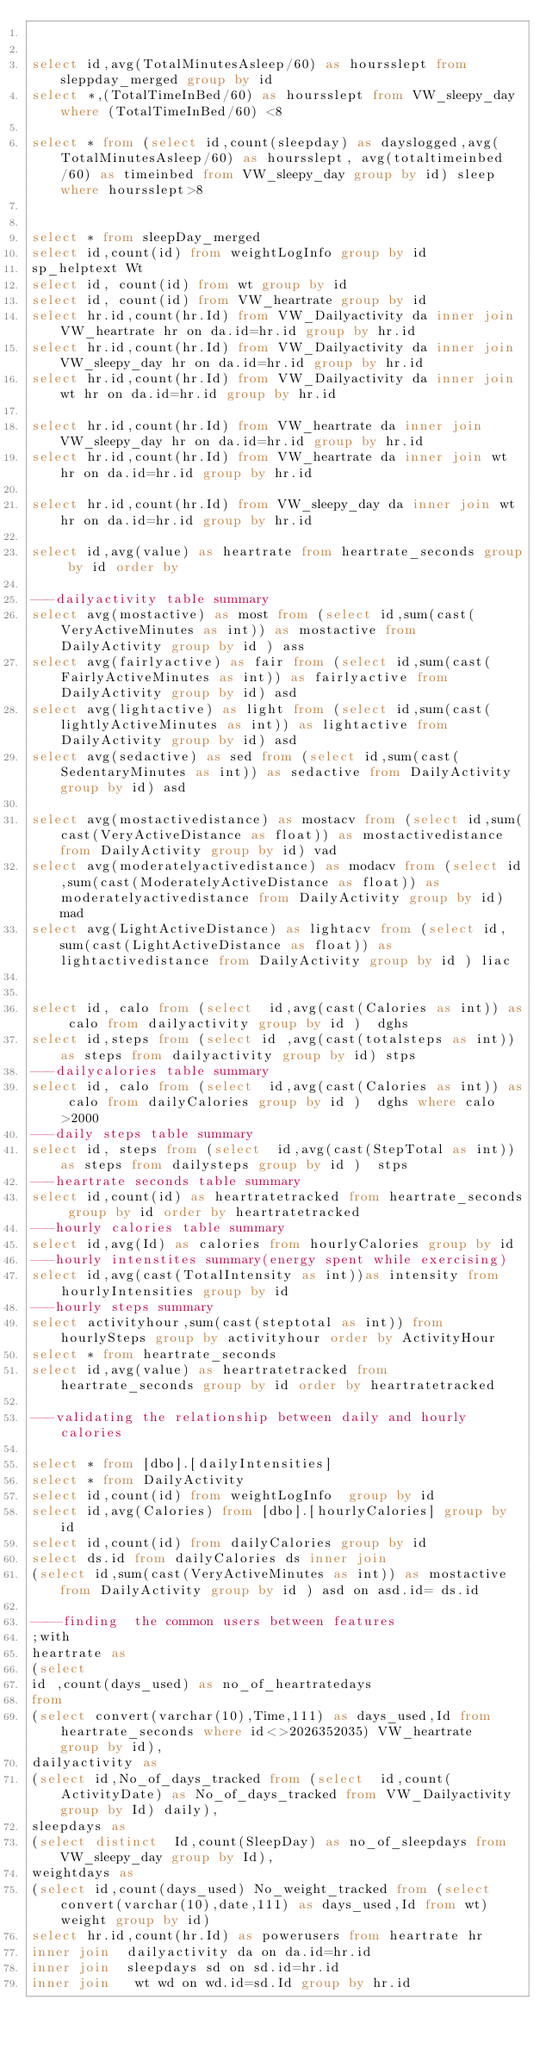<code> <loc_0><loc_0><loc_500><loc_500><_SQL_>

select id,avg(TotalMinutesAsleep/60) as hoursslept from sleppday_merged group by id
select *,(TotalTimeInBed/60) as hoursslept from VW_sleepy_day where (TotalTimeInBed/60) <8

select * from (select id,count(sleepday) as dayslogged,avg(TotalMinutesAsleep/60) as hoursslept, avg(totaltimeinbed/60) as timeinbed from VW_sleepy_day group by id) sleep where hoursslept>8


select * from sleepDay_merged
select id,count(id) from weightLogInfo group by id
sp_helptext Wt
select id, count(id) from wt group by id
select id, count(id) from VW_heartrate group by id
select hr.id,count(hr.Id) from VW_Dailyactivity da inner join VW_heartrate hr on da.id=hr.id group by hr.id
select hr.id,count(hr.Id) from VW_Dailyactivity da inner join VW_sleepy_day hr on da.id=hr.id group by hr.id
select hr.id,count(hr.Id) from VW_Dailyactivity da inner join wt hr on da.id=hr.id group by hr.id

select hr.id,count(hr.Id) from VW_heartrate da inner join VW_sleepy_day hr on da.id=hr.id group by hr.id
select hr.id,count(hr.Id) from VW_heartrate da inner join wt hr on da.id=hr.id group by hr.id

select hr.id,count(hr.Id) from VW_sleepy_day da inner join wt hr on da.id=hr.id group by hr.id

select id,avg(value) as heartrate from heartrate_seconds group by id order by 

---dailyactivity table summary
select avg(mostactive) as most from (select id,sum(cast(VeryActiveMinutes as int)) as mostactive from DailyActivity group by id ) ass
select avg(fairlyactive) as fair from (select id,sum(cast(FairlyActiveMinutes as int)) as fairlyactive from DailyActivity group by id) asd
select avg(lightactive) as light from (select id,sum(cast(lightlyActiveMinutes as int)) as lightactive from DailyActivity group by id) asd
select avg(sedactive) as sed from (select id,sum(cast(SedentaryMinutes as int)) as sedactive from DailyActivity group by id) asd
 
select avg(mostactivedistance) as mostacv from (select id,sum(cast(VeryActiveDistance as float)) as mostactivedistance from DailyActivity group by id) vad
select avg(moderatelyactivedistance) as modacv from (select id,sum(cast(ModeratelyActiveDistance as float)) as moderatelyactivedistance from DailyActivity group by id)  mad
select avg(LightActiveDistance) as lightacv from (select id,sum(cast(LightActiveDistance as float)) as lightactivedistance from DailyActivity group by id ) liac


select id, calo from (select  id,avg(cast(Calories as int)) as calo from dailyactivity group by id )  dghs 
select id,steps from (select id ,avg(cast(totalsteps as int)) as steps from dailyactivity group by id) stps
---dailycalories table summary
select id, calo from (select  id,avg(cast(Calories as int)) as calo from dailyCalories group by id )  dghs where calo >2000
---daily steps table summary
select id, steps from (select  id,avg(cast(StepTotal as int)) as steps from dailysteps group by id )  stps
---heartrate seconds table summary
select id,count(id) as heartratetracked from heartrate_seconds group by id order by heartratetracked
---hourly calories table summary
select id,avg(Id) as calories from hourlyCalories group by id
---hourly intenstites summary(energy spent while exercising)
select id,avg(cast(TotalIntensity as int))as intensity from hourlyIntensities group by id
---hourly steps summary
select activityhour,sum(cast(steptotal as int)) from hourlySteps group by activityhour order by ActivityHour
select * from heartrate_seconds
select id,avg(value) as heartratetracked from heartrate_seconds group by id order by heartratetracked

---validating the relationship between daily and hourly calories

select * from [dbo].[dailyIntensities]
select * from DailyActivity
select id,count(id) from weightLogInfo  group by id
select id,avg(Calories) from [dbo].[hourlyCalories] group by id
select id,count(id) from dailyCalories group by id
select ds.id from dailyCalories ds inner join 
(select id,sum(cast(VeryActiveMinutes as int)) as mostactive from DailyActivity group by id ) asd on asd.id= ds.id

----finding  the common users between features
;with 
heartrate as 
(select 
id ,count(days_used) as no_of_heartratedays
from 
(select convert(varchar(10),Time,111) as days_used,Id from heartrate_seconds where id<>2026352035) VW_heartrate  group by id),
dailyactivity as
(select id,No_of_days_tracked from (select  id,count(ActivityDate) as No_of_days_tracked from VW_Dailyactivity group by Id) daily),
sleepdays as
(select distinct  Id,count(SleepDay) as no_of_sleepdays from VW_sleepy_day group by Id),
weightdays as 
(select id,count(days_used) No_weight_tracked from (select convert(varchar(10),date,111) as days_used,Id from wt) weight group by id)
select hr.id,count(hr.Id) as powerusers from heartrate hr 
inner join  dailyactivity da on da.id=hr.id
inner join  sleepdays sd on sd.id=hr.id
inner join   wt wd on wd.id=sd.Id group by hr.id


</code> 